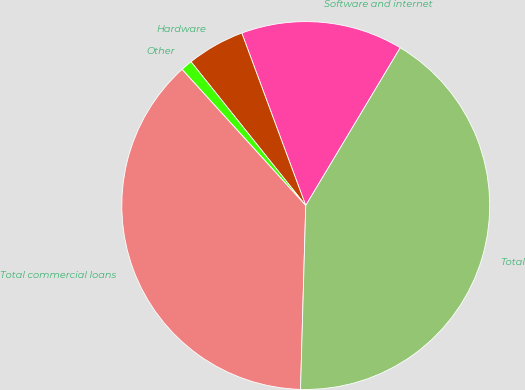<chart> <loc_0><loc_0><loc_500><loc_500><pie_chart><fcel>Software and internet<fcel>Hardware<fcel>Other<fcel>Total commercial loans<fcel>Total<nl><fcel>14.24%<fcel>5.07%<fcel>1.02%<fcel>37.81%<fcel>41.86%<nl></chart> 